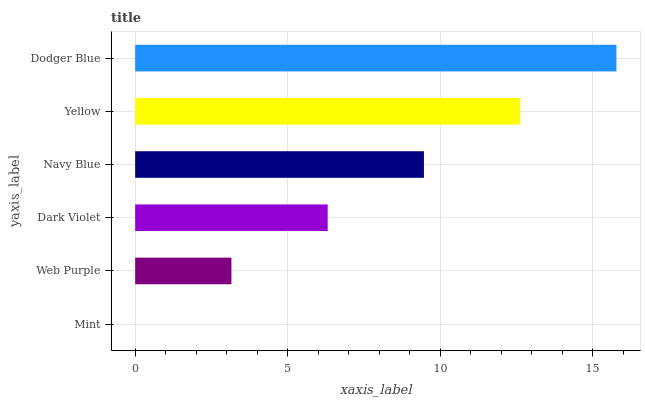Is Mint the minimum?
Answer yes or no. Yes. Is Dodger Blue the maximum?
Answer yes or no. Yes. Is Web Purple the minimum?
Answer yes or no. No. Is Web Purple the maximum?
Answer yes or no. No. Is Web Purple greater than Mint?
Answer yes or no. Yes. Is Mint less than Web Purple?
Answer yes or no. Yes. Is Mint greater than Web Purple?
Answer yes or no. No. Is Web Purple less than Mint?
Answer yes or no. No. Is Navy Blue the high median?
Answer yes or no. Yes. Is Dark Violet the low median?
Answer yes or no. Yes. Is Dodger Blue the high median?
Answer yes or no. No. Is Yellow the low median?
Answer yes or no. No. 